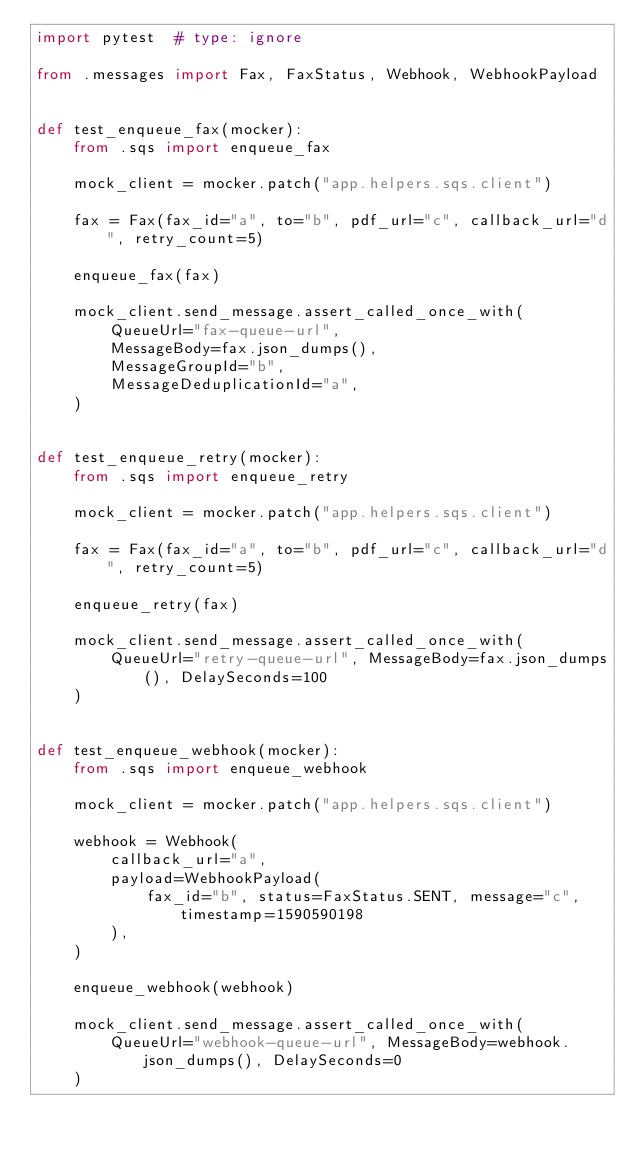Convert code to text. <code><loc_0><loc_0><loc_500><loc_500><_Python_>import pytest  # type: ignore

from .messages import Fax, FaxStatus, Webhook, WebhookPayload


def test_enqueue_fax(mocker):
    from .sqs import enqueue_fax

    mock_client = mocker.patch("app.helpers.sqs.client")

    fax = Fax(fax_id="a", to="b", pdf_url="c", callback_url="d", retry_count=5)

    enqueue_fax(fax)

    mock_client.send_message.assert_called_once_with(
        QueueUrl="fax-queue-url",
        MessageBody=fax.json_dumps(),
        MessageGroupId="b",
        MessageDeduplicationId="a",
    )


def test_enqueue_retry(mocker):
    from .sqs import enqueue_retry

    mock_client = mocker.patch("app.helpers.sqs.client")

    fax = Fax(fax_id="a", to="b", pdf_url="c", callback_url="d", retry_count=5)

    enqueue_retry(fax)

    mock_client.send_message.assert_called_once_with(
        QueueUrl="retry-queue-url", MessageBody=fax.json_dumps(), DelaySeconds=100
    )


def test_enqueue_webhook(mocker):
    from .sqs import enqueue_webhook

    mock_client = mocker.patch("app.helpers.sqs.client")

    webhook = Webhook(
        callback_url="a",
        payload=WebhookPayload(
            fax_id="b", status=FaxStatus.SENT, message="c", timestamp=1590590198
        ),
    )

    enqueue_webhook(webhook)

    mock_client.send_message.assert_called_once_with(
        QueueUrl="webhook-queue-url", MessageBody=webhook.json_dumps(), DelaySeconds=0
    )
</code> 